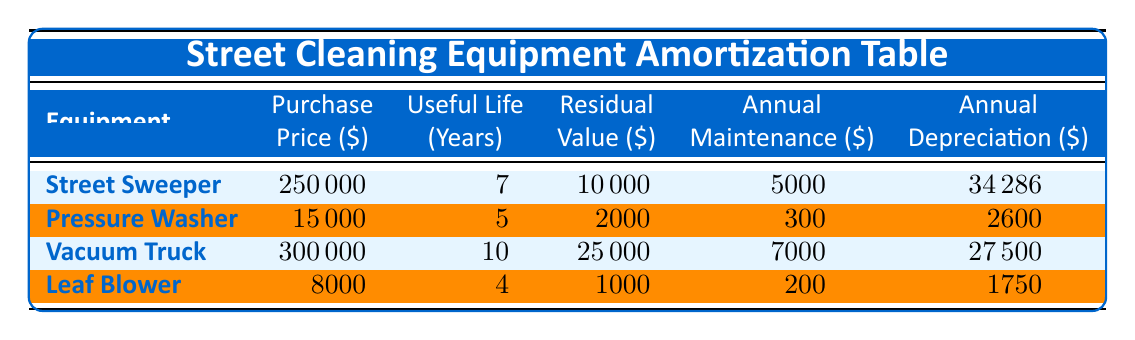What is the purchase price of the Street Sweeper? The purchase price of the Street Sweeper is listed in the table directly. It states that the purchase price is 250000.
Answer: 250000 What is the useful life of the Pressure Washer? The useful life of the Pressure Washer is specified in the table. It indicates that the useful life is 5 years.
Answer: 5 years Which equipment has the highest annual maintenance cost? By examining the annual maintenance costs in the table, the Street Sweeper has an annual maintenance cost of 5000, which is higher than the others (300, 7000, 200).
Answer: Street Sweeper What is the total purchase price of all the equipment? Adding the purchase prices of all equipment gives: 250000 (Street Sweeper) + 15000 (Pressure Washer) + 300000 (Vacuum Truck) + 8000 (Leaf Blower) = 573000.
Answer: 573000 Is the residual value of the Leaf Blower greater than 1000? The residual value of the Leaf Blower is 1000, which is not greater than 1000, thus the answer is no.
Answer: No What is the average annual maintenance cost of all equipment? To find the average, add all annual maintenance costs: 5000 (Street Sweeper) + 300 (Pressure Washer) + 7000 (Vacuum Truck) + 200 (Leaf Blower) = 12300. Divide by 4 for the average: 12300 / 4 = 3075.
Answer: 3075 Which equipment has the lowest depreciation cost per year? The yearly depreciation cost for each piece of equipment is 34286 (Street Sweeper), 2600 (Pressure Washer), 27500 (Vacuum Truck), and 1750 (Leaf Blower). The Leaf Blower has the lowest at 1750.
Answer: Leaf Blower Is the total annual cost (maintenance + depreciation) for the Vacuum Truck greater than 10000? The total annual cost for the Vacuum Truck is calculated as: 7000 (annual maintenance) + 27500 (depreciation) = 34500, which is greater than 10000.
Answer: Yes What is the difference in annual maintenance costs between the Street Sweeper and the Leaf Blower? The annual maintenance cost of the Street Sweeper is 5000 and that of the Leaf Blower is 200. The difference is: 5000 - 200 = 4800.
Answer: 4800 